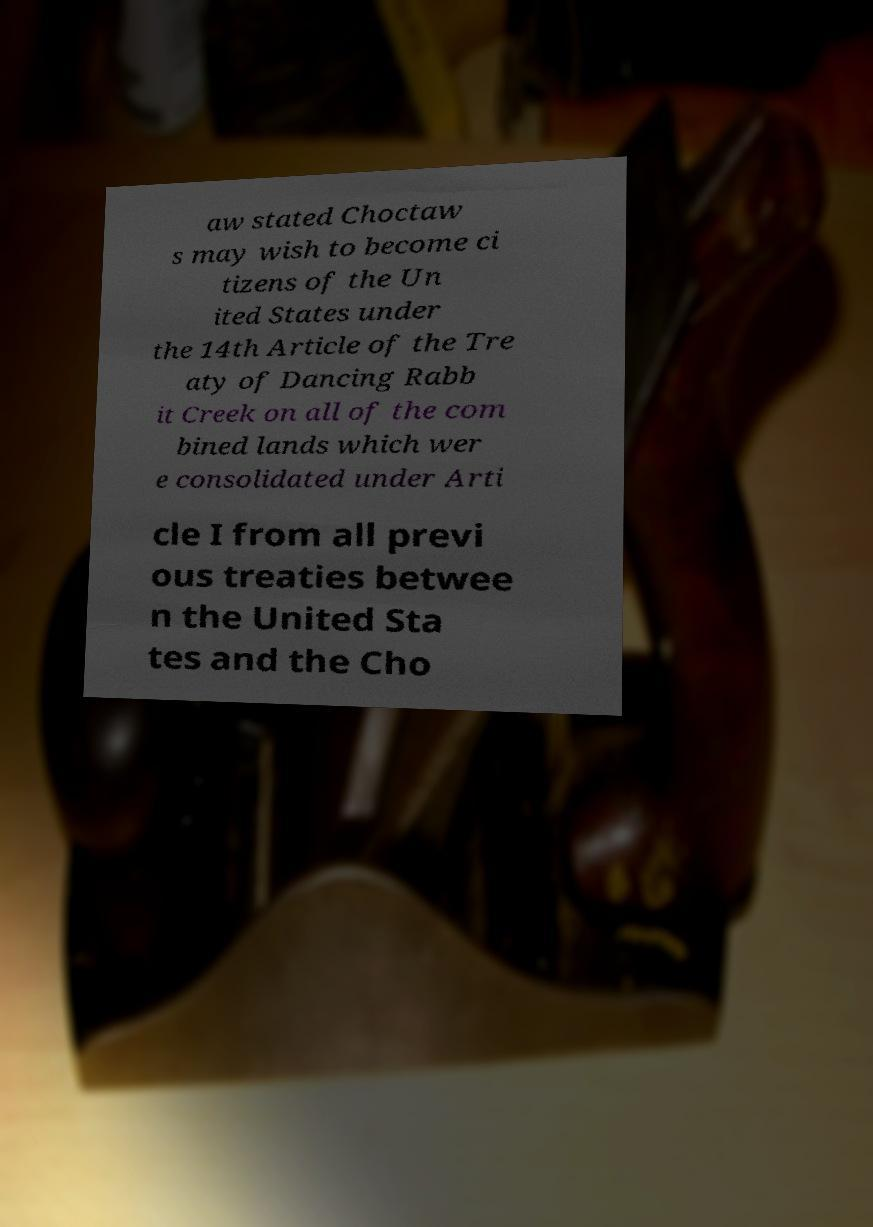Can you accurately transcribe the text from the provided image for me? aw stated Choctaw s may wish to become ci tizens of the Un ited States under the 14th Article of the Tre aty of Dancing Rabb it Creek on all of the com bined lands which wer e consolidated under Arti cle I from all previ ous treaties betwee n the United Sta tes and the Cho 